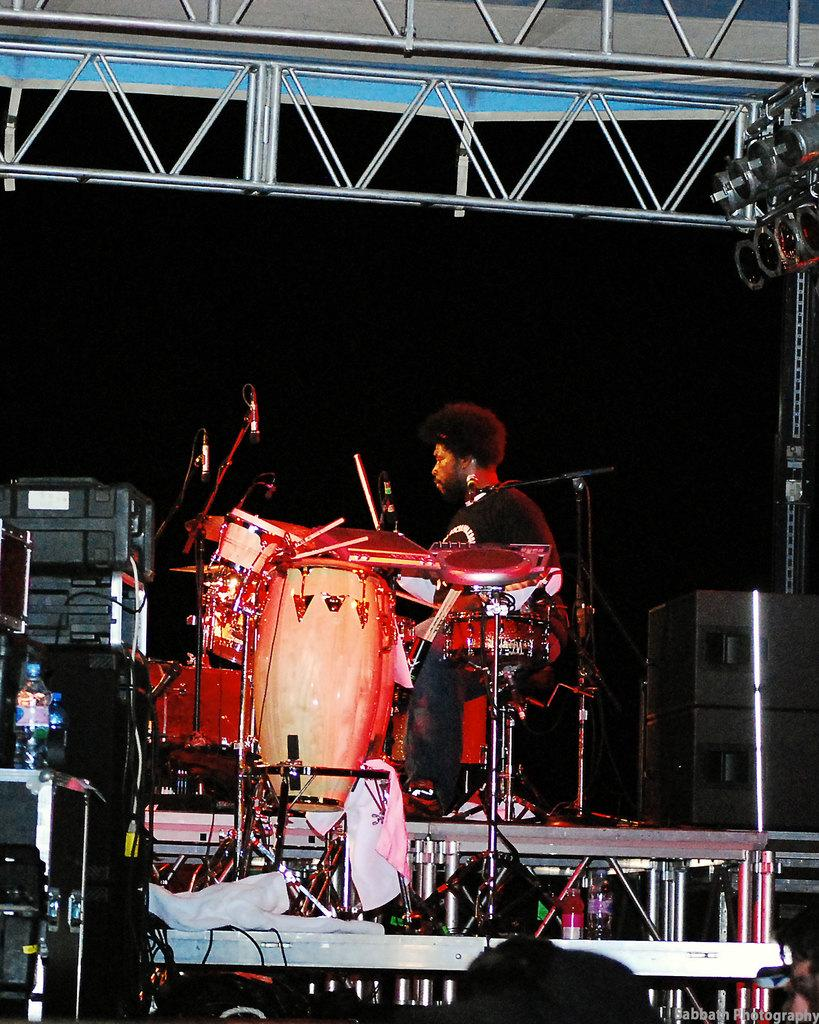What is the man in the image doing? The man is sitting on a chair in the image. What object is present that is commonly used for amplifying sound? There is a microphone (mic) in the image. What type of objects are present that are typically used for creating music? There are musical instruments in the image. What is the container in the image that might hold a liquid? There is a bottle in the image. What type of wool is being used to play the musical instruments in the image? There is no wool present in the image, and it is not being used to play the musical instruments. 